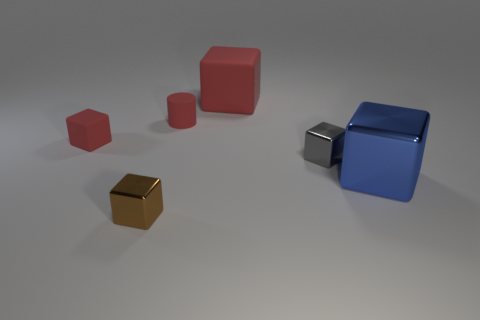How does the size of the smaller red cube compare to the blue cube? The smaller red cube is significantly less in size compared to the blue cube, approximately by a factor of four when considering volume. 